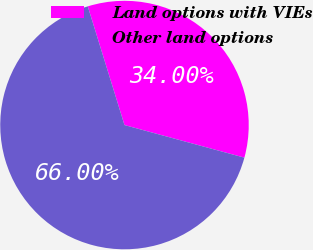<chart> <loc_0><loc_0><loc_500><loc_500><pie_chart><fcel>Land options with VIEs<fcel>Other land options<nl><fcel>34.0%<fcel>66.0%<nl></chart> 